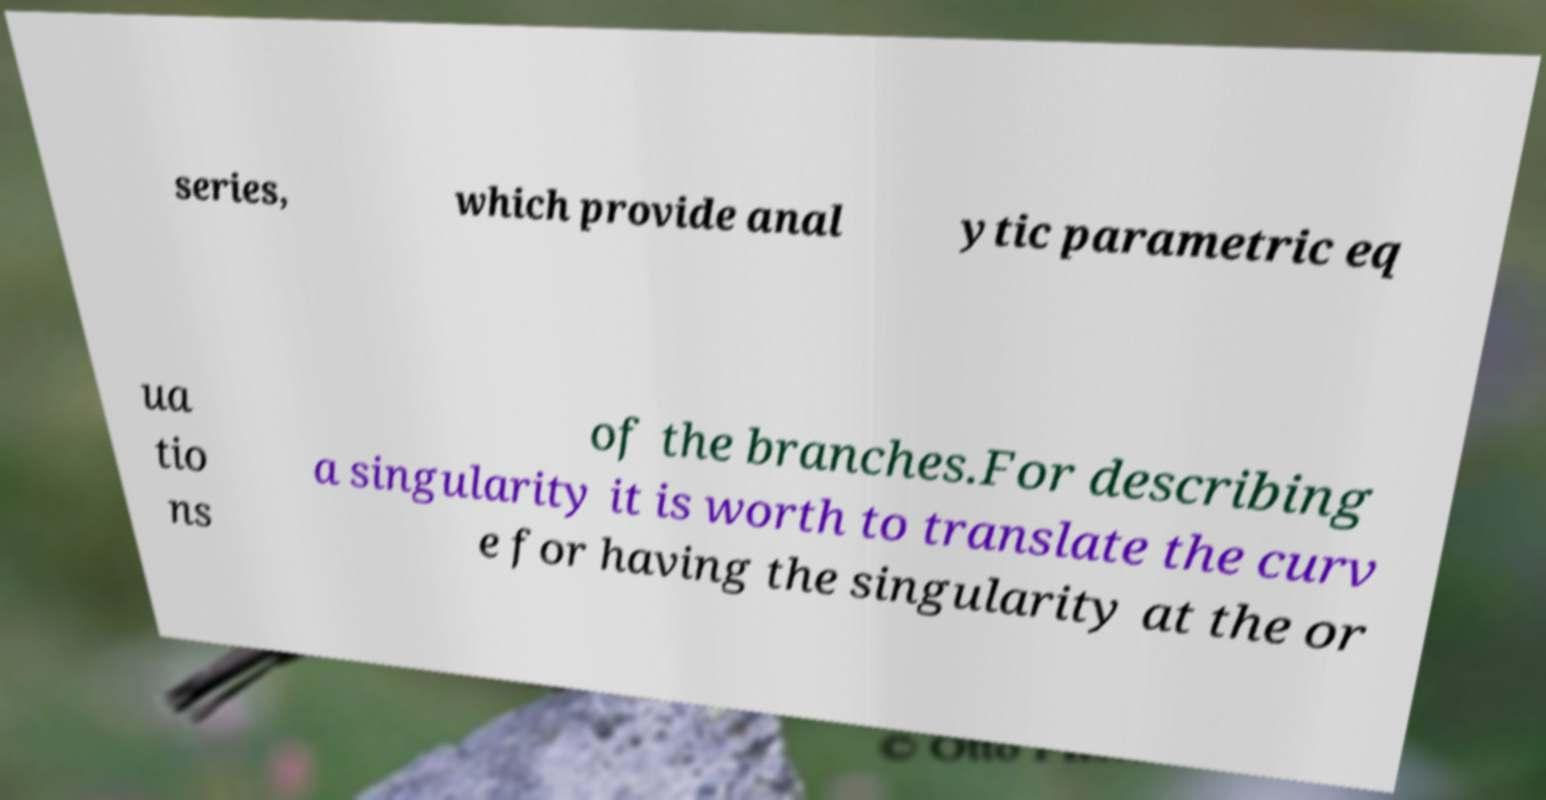Can you accurately transcribe the text from the provided image for me? series, which provide anal ytic parametric eq ua tio ns of the branches.For describing a singularity it is worth to translate the curv e for having the singularity at the or 